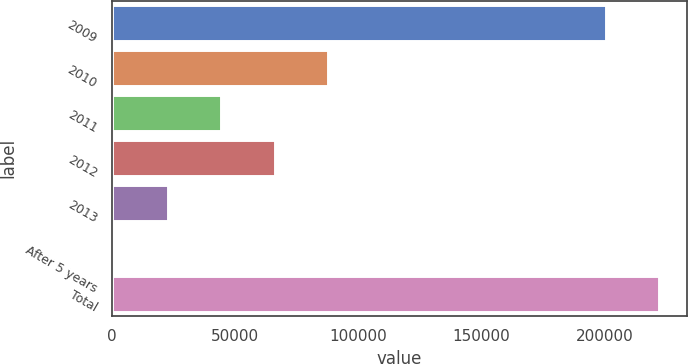<chart> <loc_0><loc_0><loc_500><loc_500><bar_chart><fcel>2009<fcel>2010<fcel>2011<fcel>2012<fcel>2013<fcel>After 5 years<fcel>Total<nl><fcel>200586<fcel>87785.2<fcel>44293.6<fcel>66039.4<fcel>22547.8<fcel>802<fcel>222332<nl></chart> 